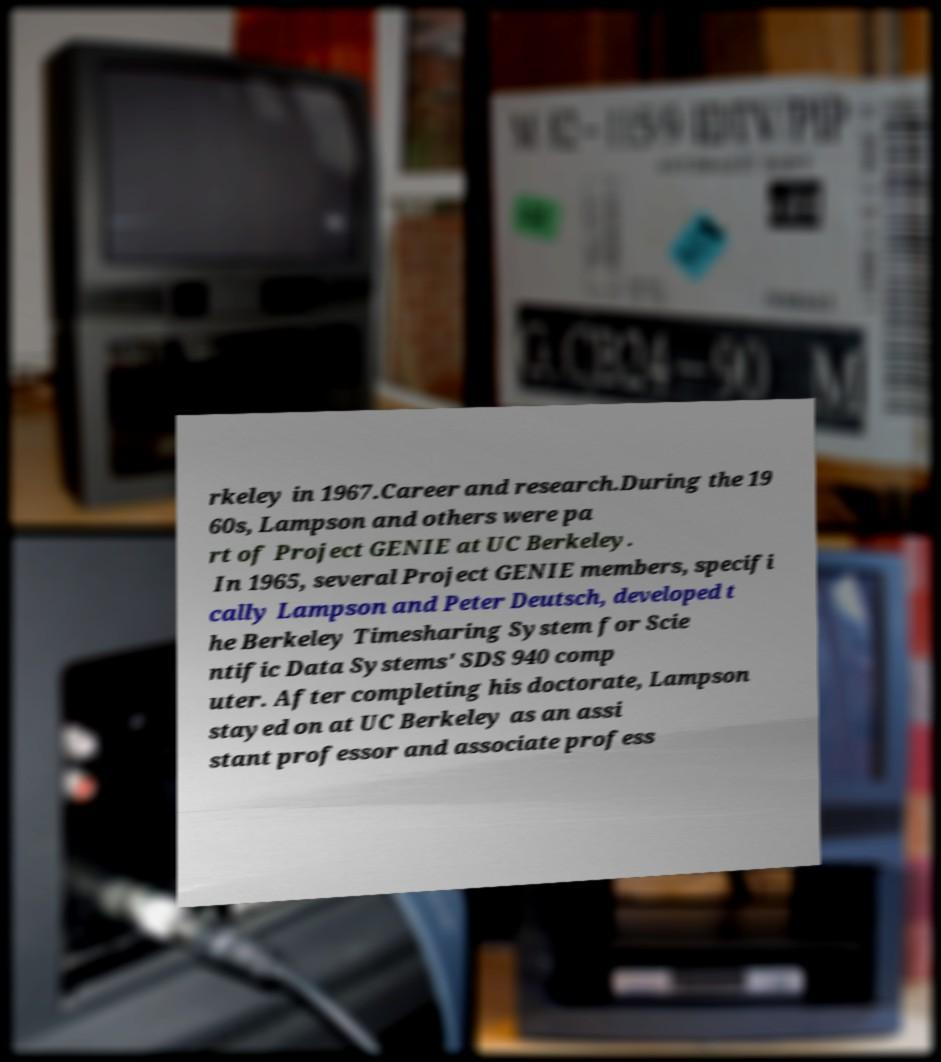Can you read and provide the text displayed in the image?This photo seems to have some interesting text. Can you extract and type it out for me? rkeley in 1967.Career and research.During the 19 60s, Lampson and others were pa rt of Project GENIE at UC Berkeley. In 1965, several Project GENIE members, specifi cally Lampson and Peter Deutsch, developed t he Berkeley Timesharing System for Scie ntific Data Systems' SDS 940 comp uter. After completing his doctorate, Lampson stayed on at UC Berkeley as an assi stant professor and associate profess 